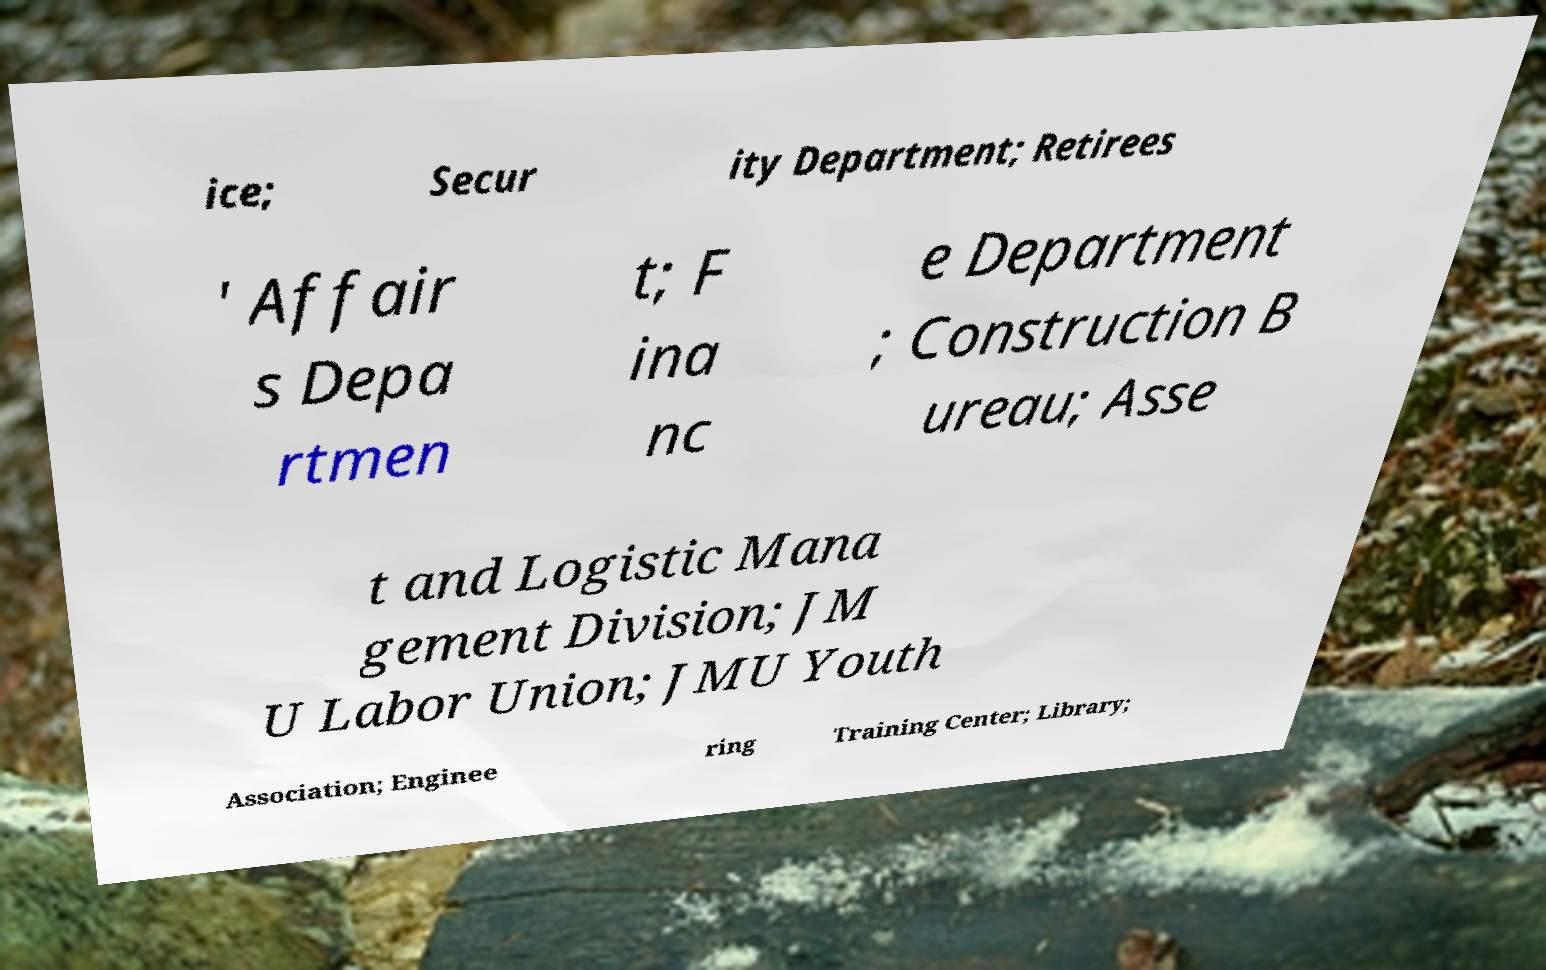Can you accurately transcribe the text from the provided image for me? ice; Secur ity Department; Retirees ' Affair s Depa rtmen t; F ina nc e Department ; Construction B ureau; Asse t and Logistic Mana gement Division; JM U Labor Union; JMU Youth Association; Enginee ring Training Center; Library; 